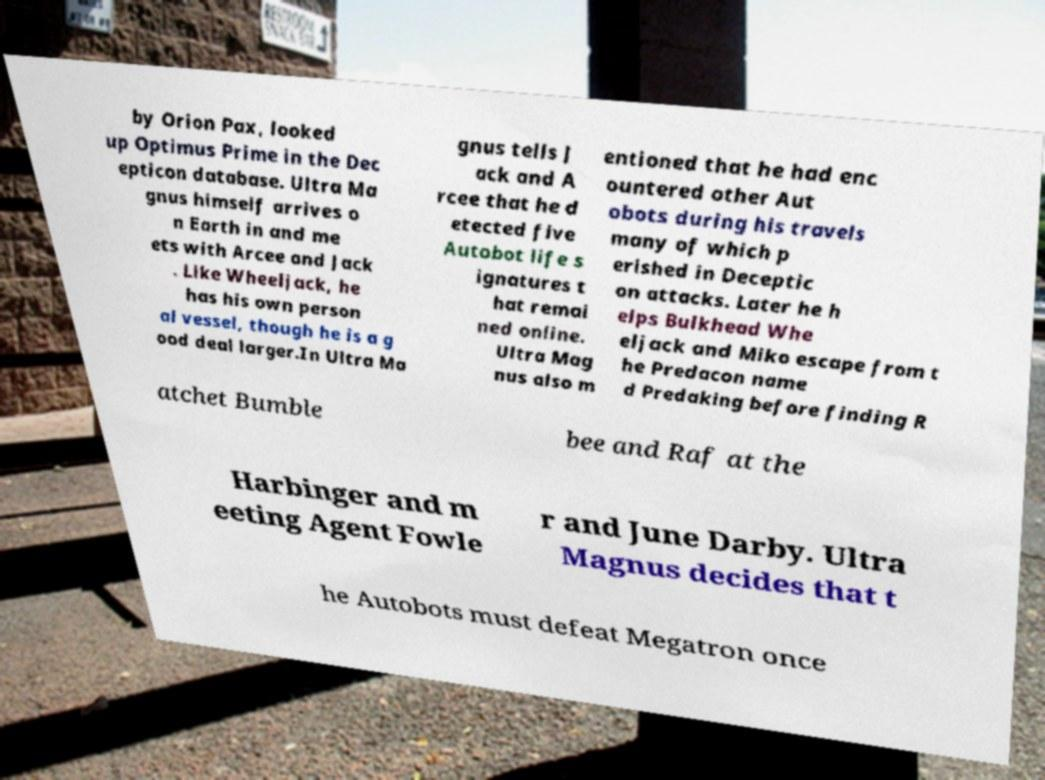Can you accurately transcribe the text from the provided image for me? by Orion Pax, looked up Optimus Prime in the Dec epticon database. Ultra Ma gnus himself arrives o n Earth in and me ets with Arcee and Jack . Like Wheeljack, he has his own person al vessel, though he is a g ood deal larger.In Ultra Ma gnus tells J ack and A rcee that he d etected five Autobot life s ignatures t hat remai ned online. Ultra Mag nus also m entioned that he had enc ountered other Aut obots during his travels many of which p erished in Deceptic on attacks. Later he h elps Bulkhead Whe eljack and Miko escape from t he Predacon name d Predaking before finding R atchet Bumble bee and Raf at the Harbinger and m eeting Agent Fowle r and June Darby. Ultra Magnus decides that t he Autobots must defeat Megatron once 